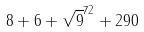Convert formula to latex. <formula><loc_0><loc_0><loc_500><loc_500>8 + 6 + \sqrt { 9 } ^ { 7 2 } + 2 9 0</formula> 